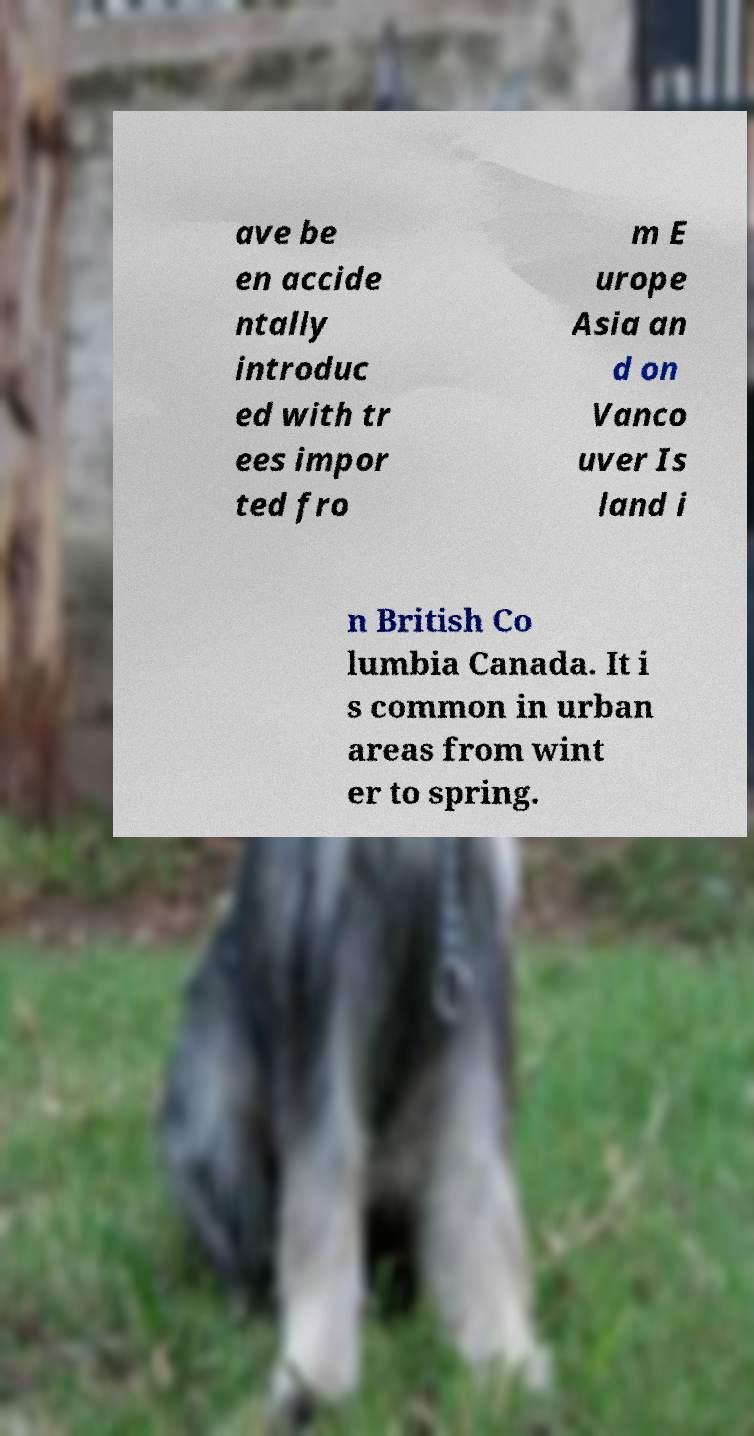What messages or text are displayed in this image? I need them in a readable, typed format. ave be en accide ntally introduc ed with tr ees impor ted fro m E urope Asia an d on Vanco uver Is land i n British Co lumbia Canada. It i s common in urban areas from wint er to spring. 